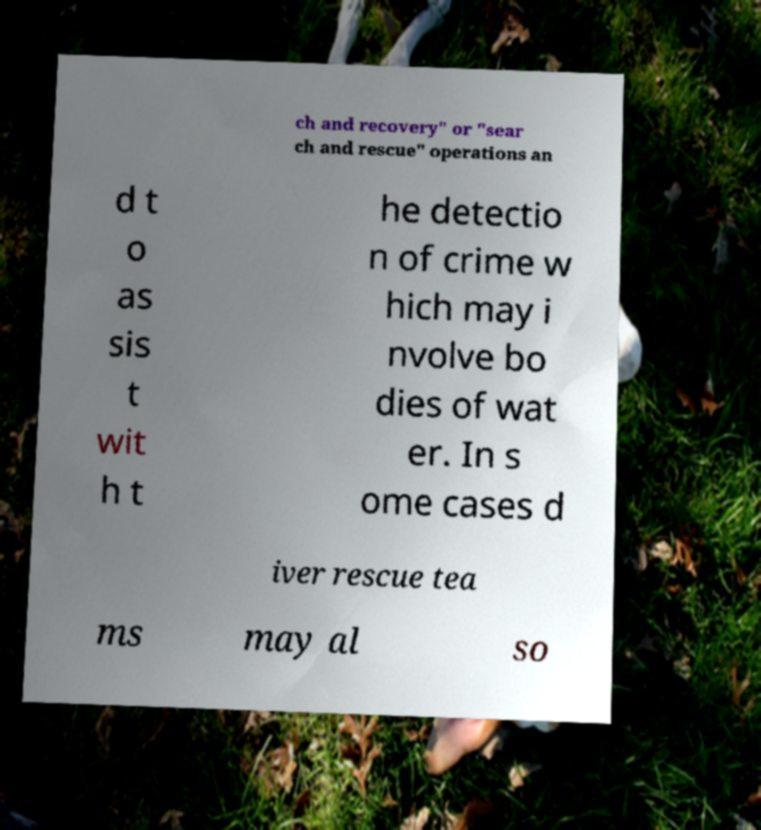For documentation purposes, I need the text within this image transcribed. Could you provide that? ch and recovery" or "sear ch and rescue" operations an d t o as sis t wit h t he detectio n of crime w hich may i nvolve bo dies of wat er. In s ome cases d iver rescue tea ms may al so 